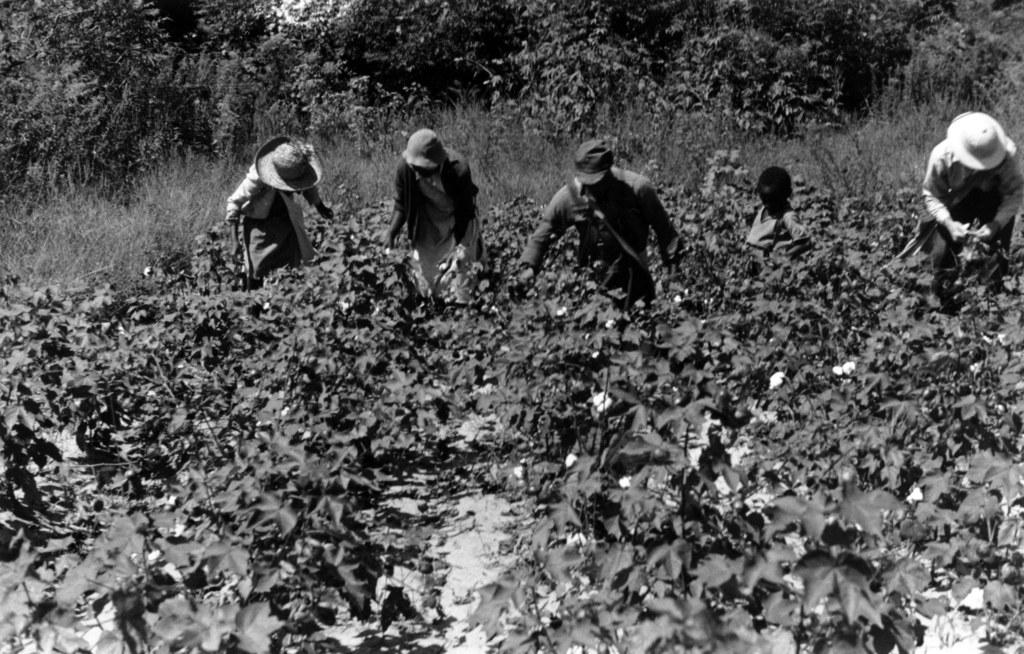What type of vegetation can be seen in the image? There are plants in the image, extending from left to right. Can you describe the people in the image? There are people visible on a path in the image. What can be seen in the background of the image? There are trees in the background of the image. How many geese are visible in the image? There are no geese present in the image. Can you describe the interaction between the people and the deer in the image? There are no deer present in the image. 